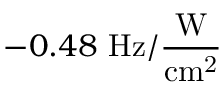Convert formula to latex. <formula><loc_0><loc_0><loc_500><loc_500>- 0 . 4 8 H z / \frac { W } { c m ^ { 2 } }</formula> 